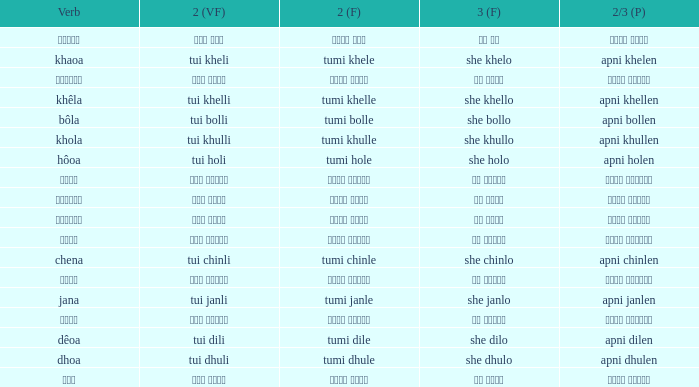What is the verb for তুমি খেলে? খাওয়া. 